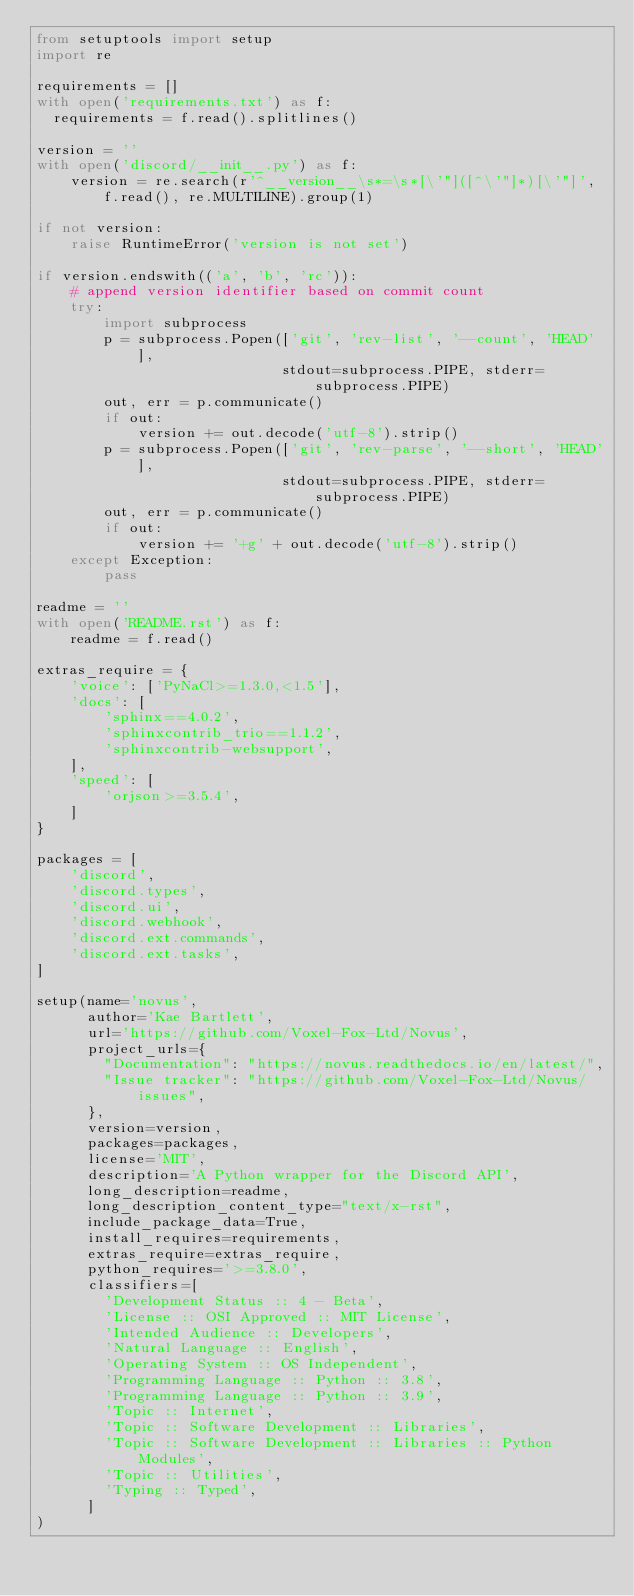<code> <loc_0><loc_0><loc_500><loc_500><_Python_>from setuptools import setup
import re

requirements = []
with open('requirements.txt') as f:
  requirements = f.read().splitlines()

version = ''
with open('discord/__init__.py') as f:
    version = re.search(r'^__version__\s*=\s*[\'"]([^\'"]*)[\'"]', f.read(), re.MULTILINE).group(1)

if not version:
    raise RuntimeError('version is not set')

if version.endswith(('a', 'b', 'rc')):
    # append version identifier based on commit count
    try:
        import subprocess
        p = subprocess.Popen(['git', 'rev-list', '--count', 'HEAD'],
                             stdout=subprocess.PIPE, stderr=subprocess.PIPE)
        out, err = p.communicate()
        if out:
            version += out.decode('utf-8').strip()
        p = subprocess.Popen(['git', 'rev-parse', '--short', 'HEAD'],
                             stdout=subprocess.PIPE, stderr=subprocess.PIPE)
        out, err = p.communicate()
        if out:
            version += '+g' + out.decode('utf-8').strip()
    except Exception:
        pass

readme = ''
with open('README.rst') as f:
    readme = f.read()

extras_require = {
    'voice': ['PyNaCl>=1.3.0,<1.5'],
    'docs': [
        'sphinx==4.0.2',
        'sphinxcontrib_trio==1.1.2',
        'sphinxcontrib-websupport',
    ],
    'speed': [
        'orjson>=3.5.4',
    ]
}

packages = [
    'discord',
    'discord.types',
    'discord.ui',
    'discord.webhook',
    'discord.ext.commands',
    'discord.ext.tasks',
]

setup(name='novus',
      author='Kae Bartlett',
      url='https://github.com/Voxel-Fox-Ltd/Novus',
      project_urls={
        "Documentation": "https://novus.readthedocs.io/en/latest/",
        "Issue tracker": "https://github.com/Voxel-Fox-Ltd/Novus/issues",
      },
      version=version,
      packages=packages,
      license='MIT',
      description='A Python wrapper for the Discord API',
      long_description=readme,
      long_description_content_type="text/x-rst",
      include_package_data=True,
      install_requires=requirements,
      extras_require=extras_require,
      python_requires='>=3.8.0',
      classifiers=[
        'Development Status :: 4 - Beta',
        'License :: OSI Approved :: MIT License',
        'Intended Audience :: Developers',
        'Natural Language :: English',
        'Operating System :: OS Independent',
        'Programming Language :: Python :: 3.8',
        'Programming Language :: Python :: 3.9',
        'Topic :: Internet',
        'Topic :: Software Development :: Libraries',
        'Topic :: Software Development :: Libraries :: Python Modules',
        'Topic :: Utilities',
        'Typing :: Typed',
      ]
)
</code> 